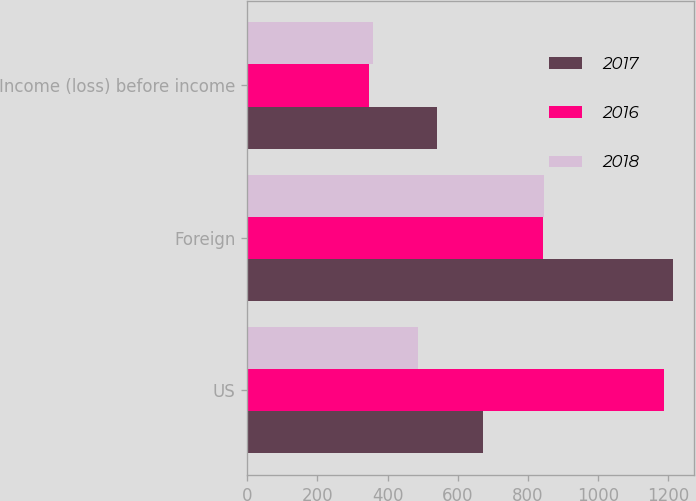Convert chart to OTSL. <chart><loc_0><loc_0><loc_500><loc_500><stacked_bar_chart><ecel><fcel>US<fcel>Foreign<fcel>Income (loss) before income<nl><fcel>2017<fcel>672<fcel>1213<fcel>541<nl><fcel>2016<fcel>1189<fcel>843<fcel>346<nl><fcel>2018<fcel>487<fcel>845<fcel>358<nl></chart> 